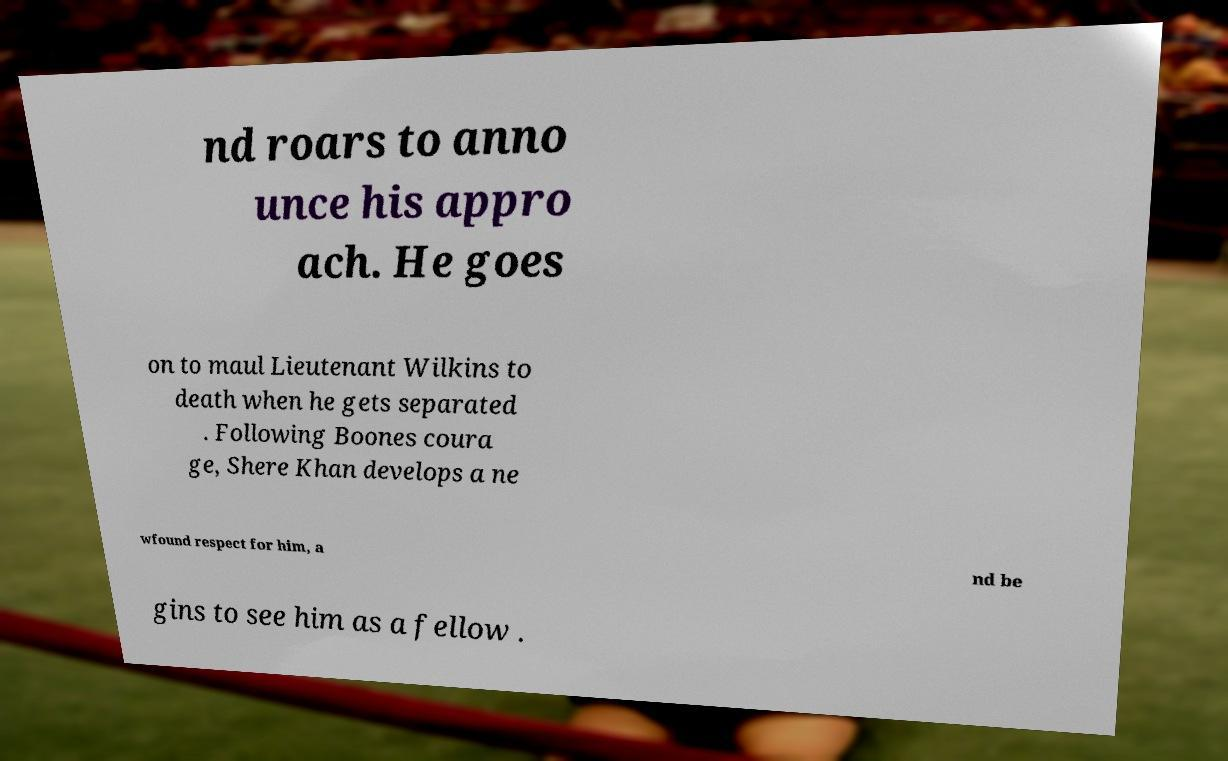Can you read and provide the text displayed in the image?This photo seems to have some interesting text. Can you extract and type it out for me? nd roars to anno unce his appro ach. He goes on to maul Lieutenant Wilkins to death when he gets separated . Following Boones coura ge, Shere Khan develops a ne wfound respect for him, a nd be gins to see him as a fellow . 